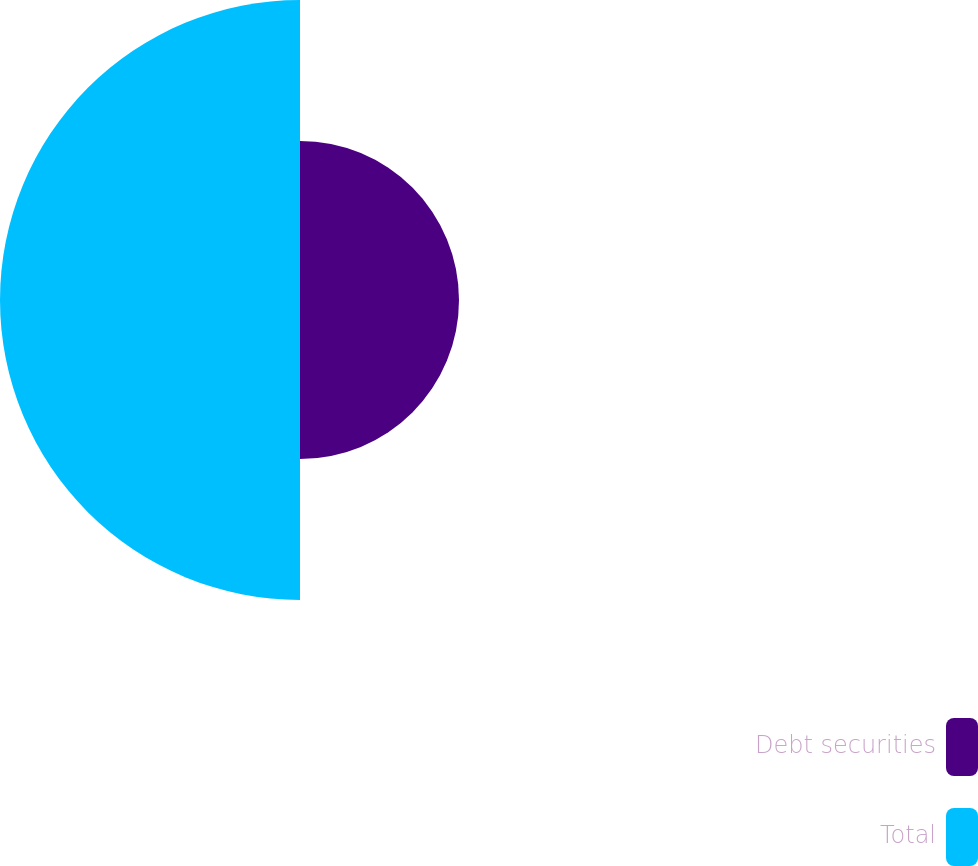Convert chart. <chart><loc_0><loc_0><loc_500><loc_500><pie_chart><fcel>Debt securities<fcel>Total<nl><fcel>34.64%<fcel>65.36%<nl></chart> 